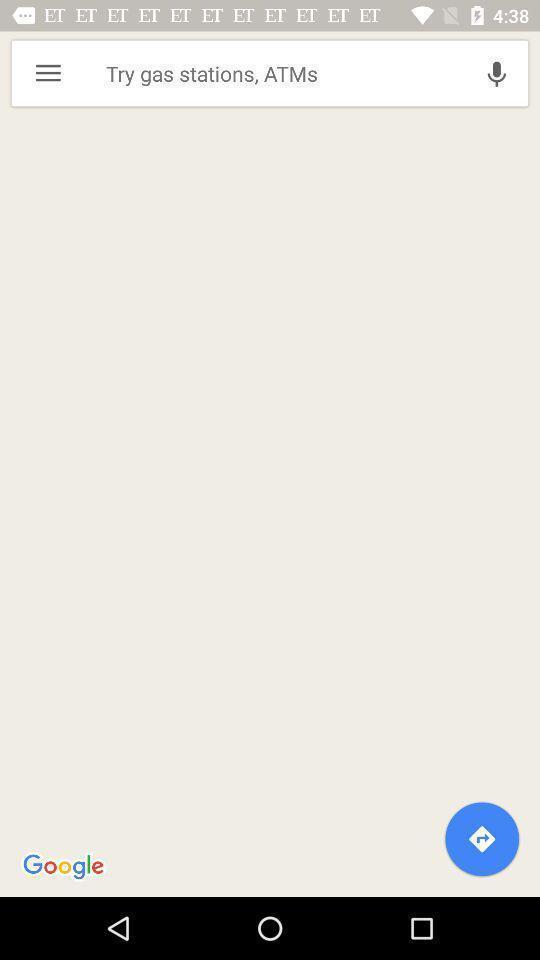Describe this image in words. Search the gps for outdoor activities. 